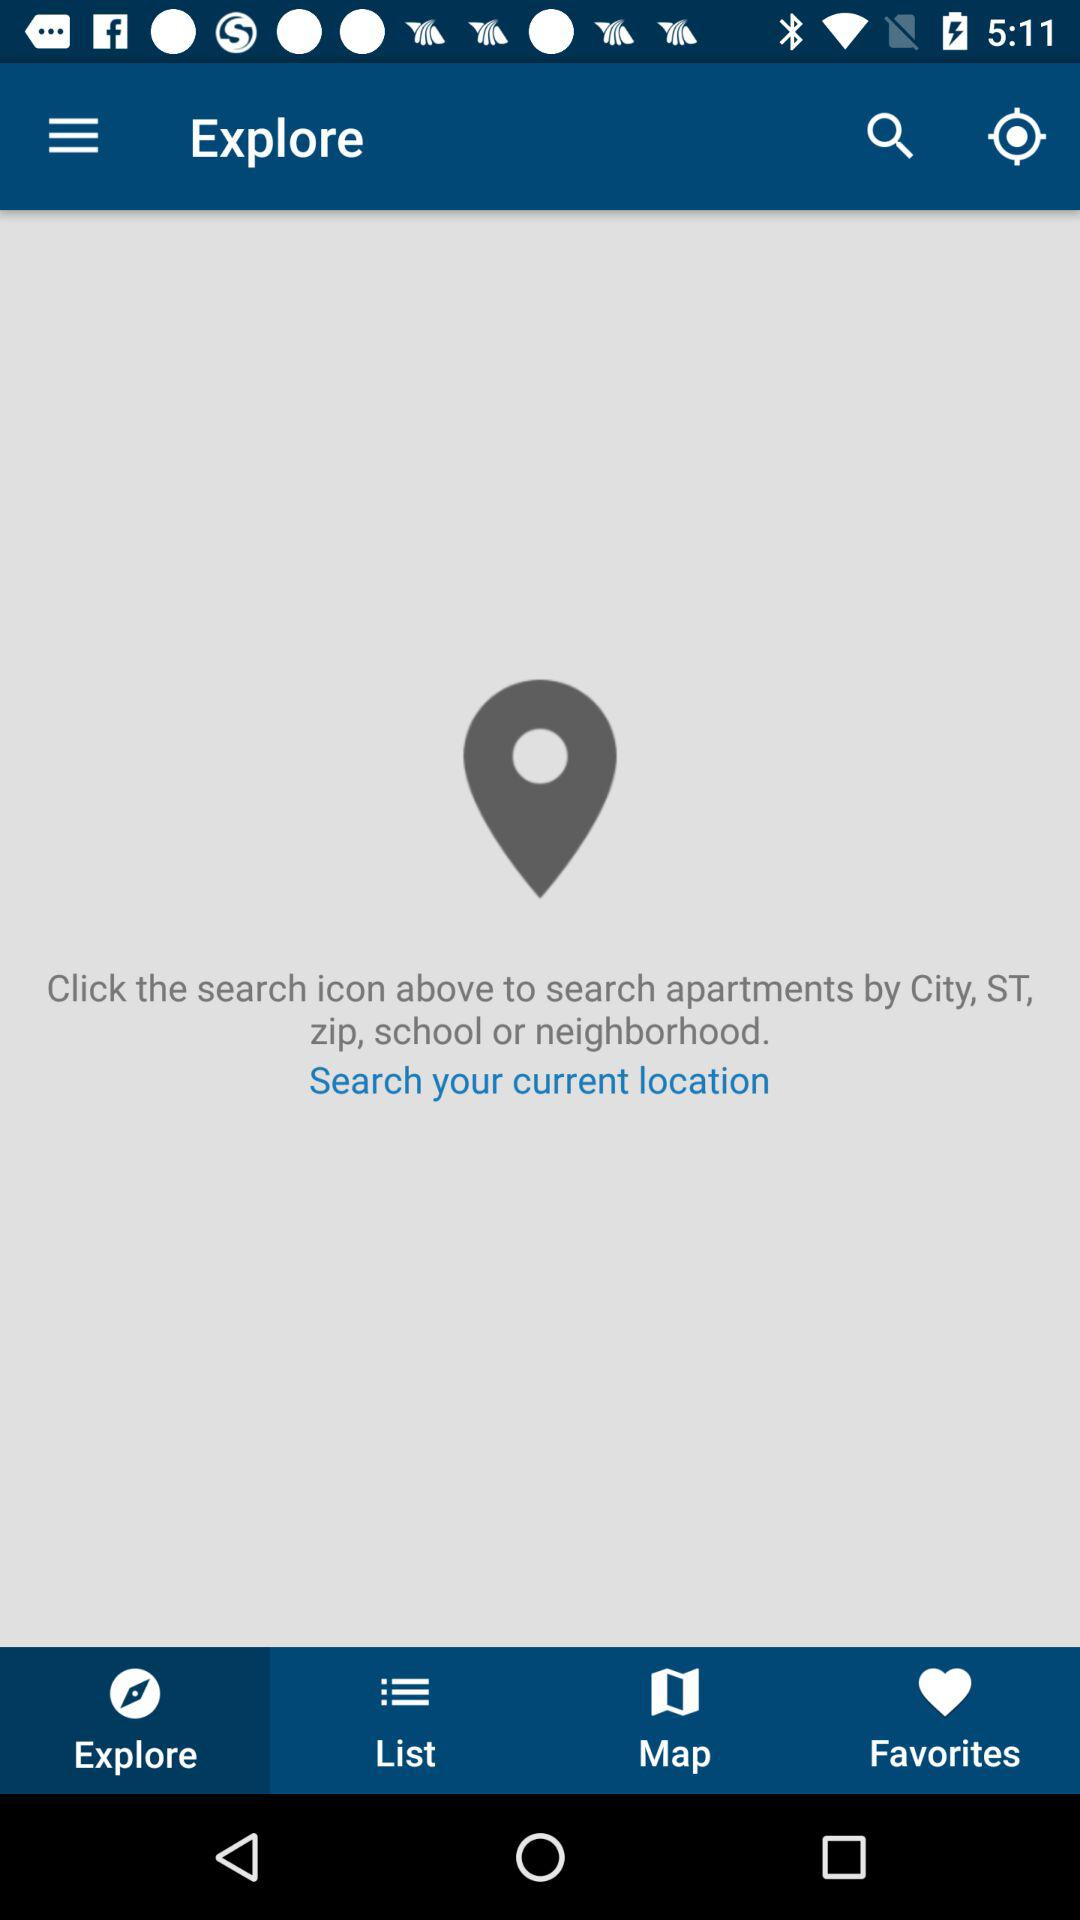Which tab is selected? The selected tab is "Explore". 